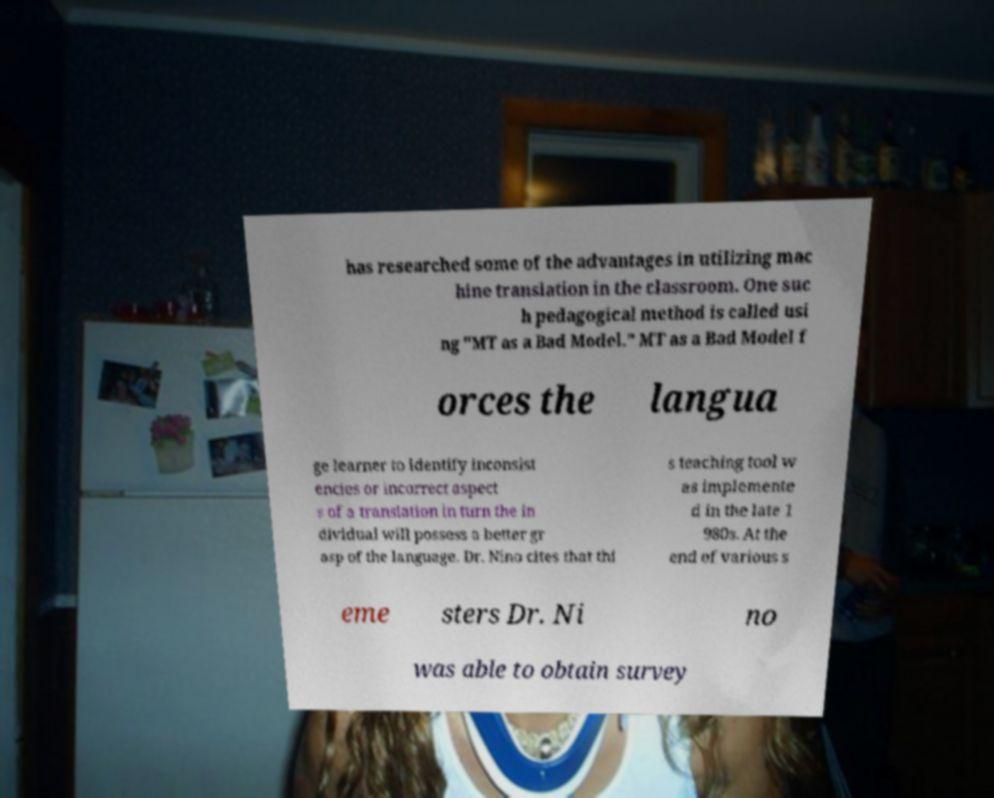Can you accurately transcribe the text from the provided image for me? has researched some of the advantages in utilizing mac hine translation in the classroom. One suc h pedagogical method is called usi ng "MT as a Bad Model." MT as a Bad Model f orces the langua ge learner to identify inconsist encies or incorrect aspect s of a translation in turn the in dividual will possess a better gr asp of the language. Dr. Nino cites that thi s teaching tool w as implemente d in the late 1 980s. At the end of various s eme sters Dr. Ni no was able to obtain survey 